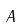<formula> <loc_0><loc_0><loc_500><loc_500>A</formula> 